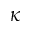Convert formula to latex. <formula><loc_0><loc_0><loc_500><loc_500>{ \kappa }</formula> 